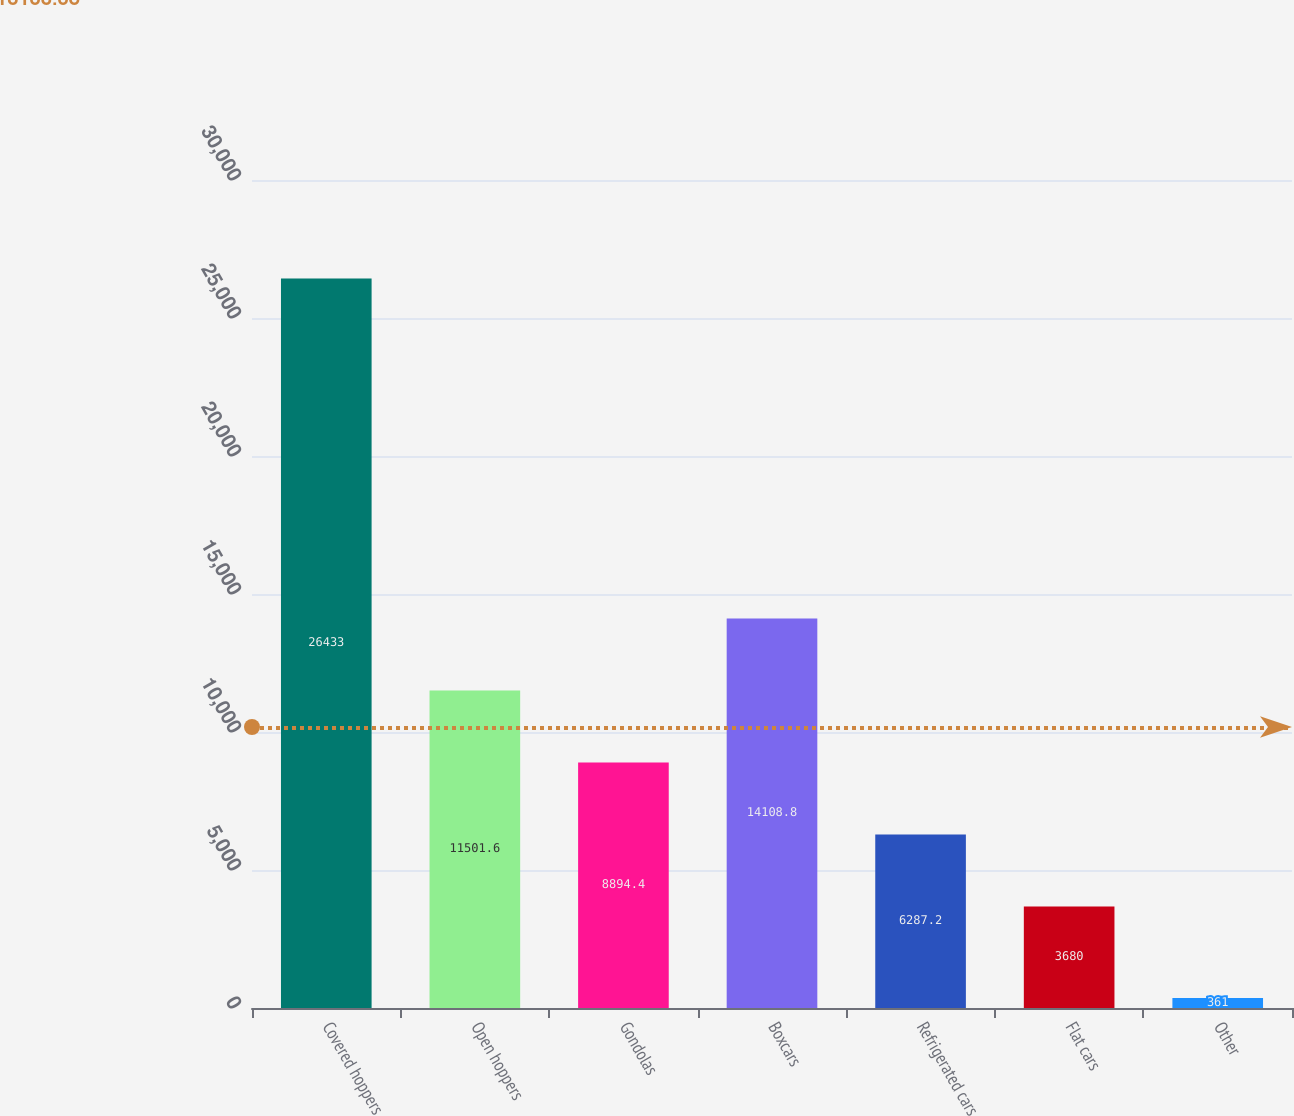Convert chart to OTSL. <chart><loc_0><loc_0><loc_500><loc_500><bar_chart><fcel>Covered hoppers<fcel>Open hoppers<fcel>Gondolas<fcel>Boxcars<fcel>Refrigerated cars<fcel>Flat cars<fcel>Other<nl><fcel>26433<fcel>11501.6<fcel>8894.4<fcel>14108.8<fcel>6287.2<fcel>3680<fcel>361<nl></chart> 